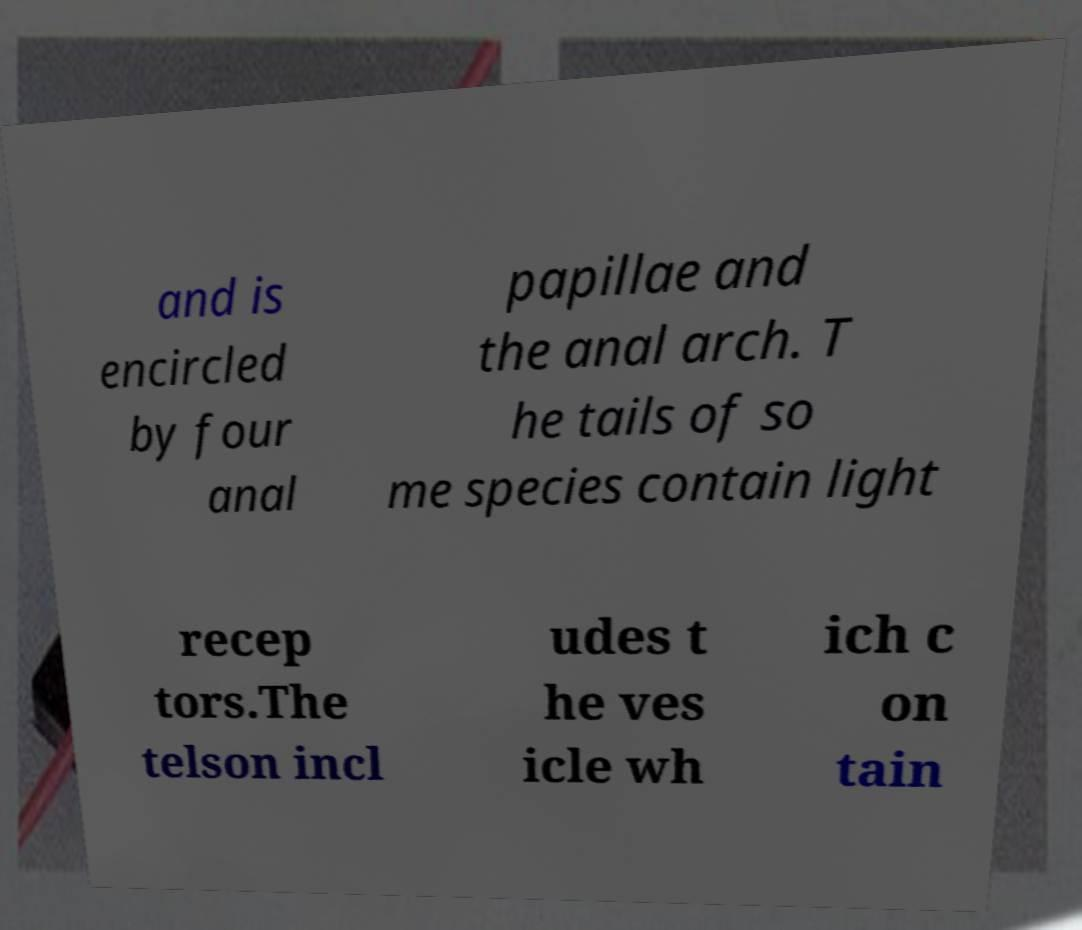I need the written content from this picture converted into text. Can you do that? and is encircled by four anal papillae and the anal arch. T he tails of so me species contain light recep tors.The telson incl udes t he ves icle wh ich c on tain 